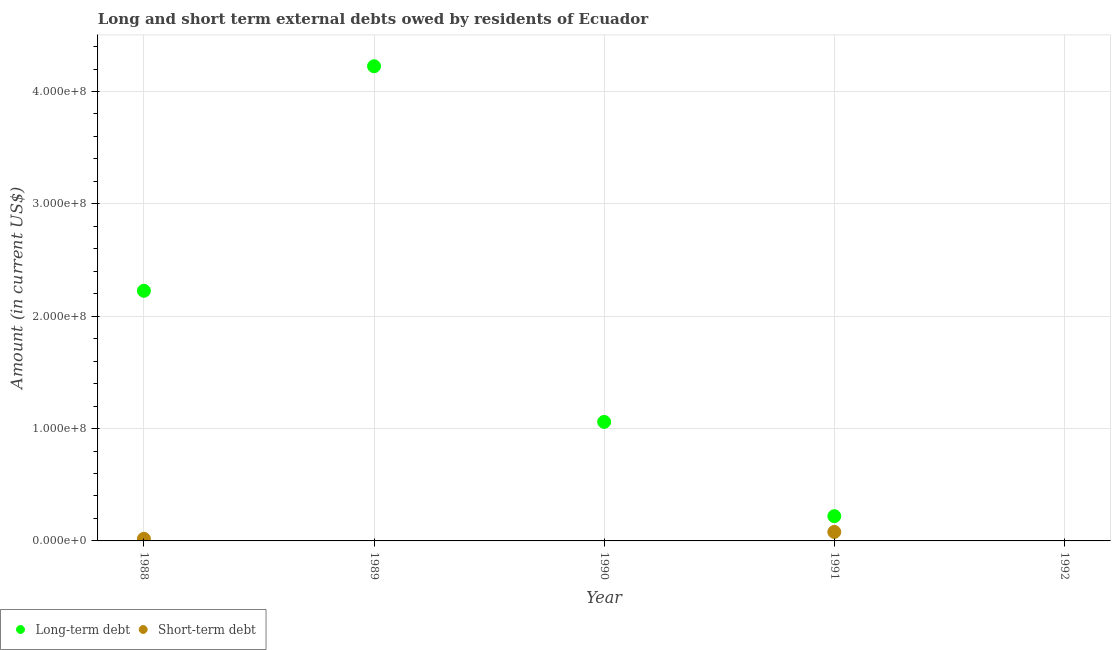How many different coloured dotlines are there?
Provide a short and direct response. 2. What is the short-term debts owed by residents in 1991?
Ensure brevity in your answer.  8.00e+06. Across all years, what is the maximum long-term debts owed by residents?
Your answer should be very brief. 4.22e+08. In which year was the short-term debts owed by residents maximum?
Give a very brief answer. 1991. What is the total long-term debts owed by residents in the graph?
Your answer should be very brief. 7.73e+08. What is the difference between the long-term debts owed by residents in 1988 and that in 1991?
Make the answer very short. 2.01e+08. What is the difference between the long-term debts owed by residents in 1990 and the short-term debts owed by residents in 1992?
Make the answer very short. 1.06e+08. What is the average short-term debts owed by residents per year?
Your answer should be very brief. 1.97e+06. In the year 1988, what is the difference between the short-term debts owed by residents and long-term debts owed by residents?
Your answer should be very brief. -2.21e+08. In how many years, is the long-term debts owed by residents greater than 220000000 US$?
Offer a very short reply. 2. What is the ratio of the long-term debts owed by residents in 1989 to that in 1991?
Offer a terse response. 19.17. Is the long-term debts owed by residents in 1988 less than that in 1991?
Keep it short and to the point. No. What is the difference between the highest and the second highest long-term debts owed by residents?
Offer a very short reply. 2.00e+08. What is the difference between the highest and the lowest short-term debts owed by residents?
Your answer should be very brief. 8.00e+06. Is the sum of the long-term debts owed by residents in 1988 and 1989 greater than the maximum short-term debts owed by residents across all years?
Offer a terse response. Yes. How many years are there in the graph?
Your answer should be very brief. 5. Does the graph contain any zero values?
Offer a very short reply. Yes. Does the graph contain grids?
Provide a succinct answer. Yes. Where does the legend appear in the graph?
Make the answer very short. Bottom left. What is the title of the graph?
Provide a short and direct response. Long and short term external debts owed by residents of Ecuador. Does "National Tourists" appear as one of the legend labels in the graph?
Provide a succinct answer. No. What is the label or title of the X-axis?
Offer a terse response. Year. What is the Amount (in current US$) of Long-term debt in 1988?
Your answer should be compact. 2.23e+08. What is the Amount (in current US$) in Short-term debt in 1988?
Ensure brevity in your answer.  1.86e+06. What is the Amount (in current US$) in Long-term debt in 1989?
Make the answer very short. 4.22e+08. What is the Amount (in current US$) in Short-term debt in 1989?
Your answer should be compact. 0. What is the Amount (in current US$) in Long-term debt in 1990?
Make the answer very short. 1.06e+08. What is the Amount (in current US$) of Long-term debt in 1991?
Provide a succinct answer. 2.20e+07. What is the Amount (in current US$) of Long-term debt in 1992?
Give a very brief answer. 0. Across all years, what is the maximum Amount (in current US$) in Long-term debt?
Your answer should be compact. 4.22e+08. Across all years, what is the maximum Amount (in current US$) of Short-term debt?
Ensure brevity in your answer.  8.00e+06. Across all years, what is the minimum Amount (in current US$) of Long-term debt?
Make the answer very short. 0. Across all years, what is the minimum Amount (in current US$) in Short-term debt?
Your answer should be compact. 0. What is the total Amount (in current US$) of Long-term debt in the graph?
Provide a succinct answer. 7.73e+08. What is the total Amount (in current US$) in Short-term debt in the graph?
Give a very brief answer. 9.86e+06. What is the difference between the Amount (in current US$) in Long-term debt in 1988 and that in 1989?
Provide a succinct answer. -2.00e+08. What is the difference between the Amount (in current US$) of Long-term debt in 1988 and that in 1990?
Give a very brief answer. 1.17e+08. What is the difference between the Amount (in current US$) of Long-term debt in 1988 and that in 1991?
Offer a terse response. 2.01e+08. What is the difference between the Amount (in current US$) of Short-term debt in 1988 and that in 1991?
Make the answer very short. -6.14e+06. What is the difference between the Amount (in current US$) of Long-term debt in 1989 and that in 1990?
Your response must be concise. 3.17e+08. What is the difference between the Amount (in current US$) of Long-term debt in 1989 and that in 1991?
Your answer should be very brief. 4.00e+08. What is the difference between the Amount (in current US$) in Long-term debt in 1990 and that in 1991?
Offer a terse response. 8.39e+07. What is the difference between the Amount (in current US$) in Long-term debt in 1988 and the Amount (in current US$) in Short-term debt in 1991?
Provide a succinct answer. 2.15e+08. What is the difference between the Amount (in current US$) in Long-term debt in 1989 and the Amount (in current US$) in Short-term debt in 1991?
Provide a short and direct response. 4.14e+08. What is the difference between the Amount (in current US$) of Long-term debt in 1990 and the Amount (in current US$) of Short-term debt in 1991?
Offer a very short reply. 9.80e+07. What is the average Amount (in current US$) of Long-term debt per year?
Make the answer very short. 1.55e+08. What is the average Amount (in current US$) in Short-term debt per year?
Offer a very short reply. 1.97e+06. In the year 1988, what is the difference between the Amount (in current US$) in Long-term debt and Amount (in current US$) in Short-term debt?
Provide a succinct answer. 2.21e+08. In the year 1991, what is the difference between the Amount (in current US$) in Long-term debt and Amount (in current US$) in Short-term debt?
Provide a succinct answer. 1.40e+07. What is the ratio of the Amount (in current US$) in Long-term debt in 1988 to that in 1989?
Your answer should be very brief. 0.53. What is the ratio of the Amount (in current US$) in Long-term debt in 1988 to that in 1990?
Offer a very short reply. 2.1. What is the ratio of the Amount (in current US$) in Long-term debt in 1988 to that in 1991?
Ensure brevity in your answer.  10.1. What is the ratio of the Amount (in current US$) of Short-term debt in 1988 to that in 1991?
Provide a short and direct response. 0.23. What is the ratio of the Amount (in current US$) in Long-term debt in 1989 to that in 1990?
Give a very brief answer. 3.99. What is the ratio of the Amount (in current US$) in Long-term debt in 1989 to that in 1991?
Offer a very short reply. 19.17. What is the ratio of the Amount (in current US$) of Long-term debt in 1990 to that in 1991?
Offer a very short reply. 4.81. What is the difference between the highest and the second highest Amount (in current US$) of Long-term debt?
Provide a short and direct response. 2.00e+08. What is the difference between the highest and the lowest Amount (in current US$) of Long-term debt?
Make the answer very short. 4.22e+08. 